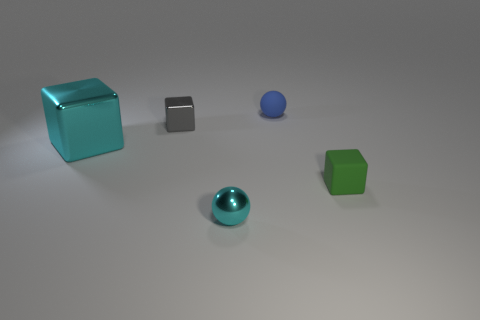Add 4 blue rubber balls. How many objects exist? 9 Subtract all cubes. How many objects are left? 2 Add 1 tiny cyan things. How many tiny cyan things are left? 2 Add 4 small spheres. How many small spheres exist? 6 Subtract 0 purple cylinders. How many objects are left? 5 Subtract all green rubber objects. Subtract all blue rubber spheres. How many objects are left? 3 